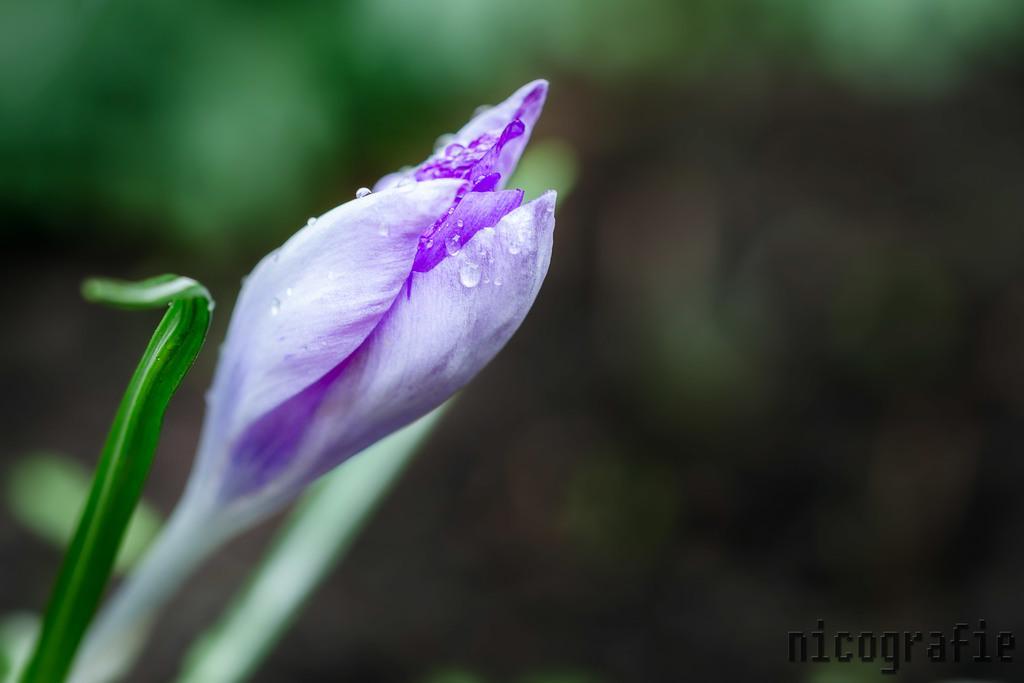Please provide a concise description of this image. In this picture we can see a flower and on flower we can see small droplets and this is a leaf attached to that may be it looks like a plant and in the background it is blurry. 